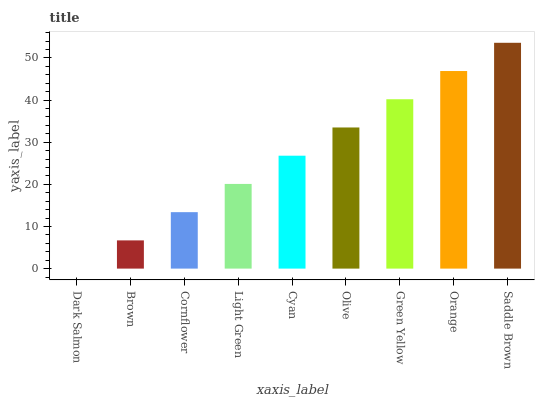Is Dark Salmon the minimum?
Answer yes or no. Yes. Is Saddle Brown the maximum?
Answer yes or no. Yes. Is Brown the minimum?
Answer yes or no. No. Is Brown the maximum?
Answer yes or no. No. Is Brown greater than Dark Salmon?
Answer yes or no. Yes. Is Dark Salmon less than Brown?
Answer yes or no. Yes. Is Dark Salmon greater than Brown?
Answer yes or no. No. Is Brown less than Dark Salmon?
Answer yes or no. No. Is Cyan the high median?
Answer yes or no. Yes. Is Cyan the low median?
Answer yes or no. Yes. Is Saddle Brown the high median?
Answer yes or no. No. Is Brown the low median?
Answer yes or no. No. 